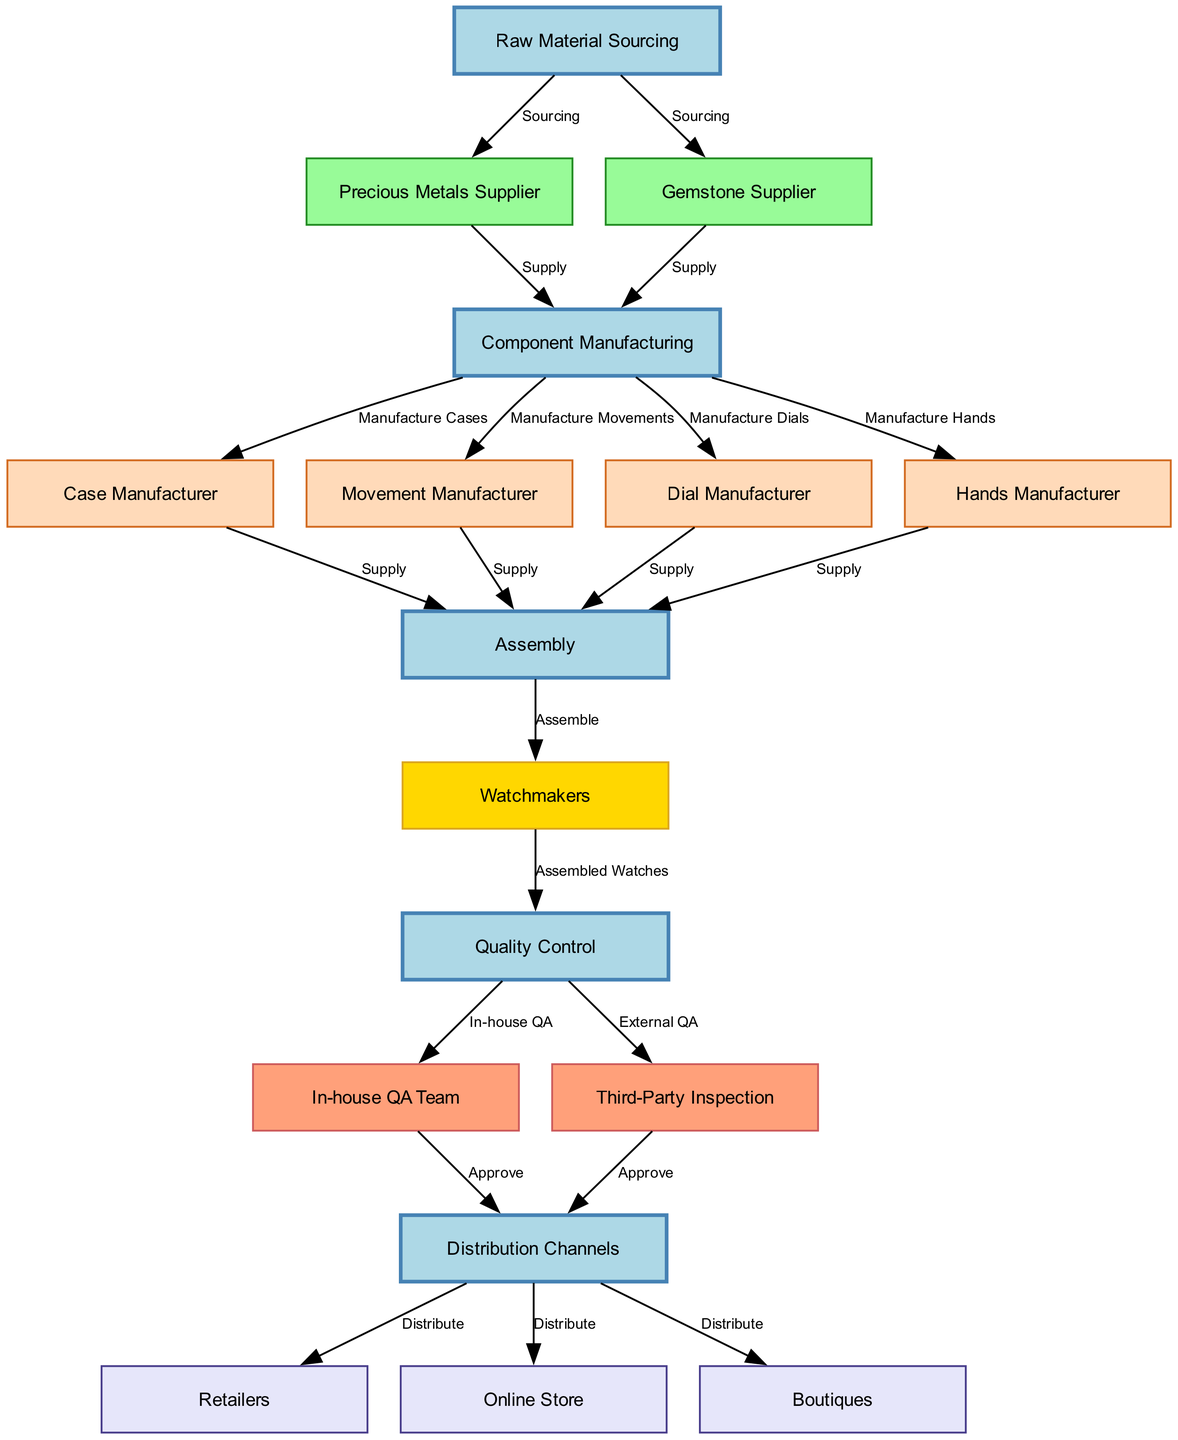What are the first two steps in the supply chain flow? The first step is "Raw Material Sourcing," followed by sourcing from "Precious Metals Supplier" and "Gemstone Supplier."
Answer: Raw Material Sourcing, Precious Metals Supplier, Gemstone Supplier How many manufacturers are involved in the component manufacturing phase? The diagram indicates there are four manufacturers involved: Case Manufacturer, Movement Manufacturer, Dial Manufacturer, and Hands Manufacturer.
Answer: Four What is the primary function of the "In-house QA Team"? The function of the "In-house QA Team" is to approve the assembled watches after the quality control checks are performed on them.
Answer: Approve Which node represents the final distribution of products? The node labeled "Distribution Channels" represents the final distribution point for the completed watches.
Answer: Distribution Channels What are the three distribution channels shown in the diagram? The three distribution channels are "Retailers," "Online Store," and "Boutiques."
Answer: Retailers, Online Store, Boutiques How does the assembly process connect the nodes? The assembly process connects from "Component Manufacturing" to "Assembly" and then to "Watchmakers," indicating direct involvement in the physical assembly of watches.
Answer: Assembly, Watchmakers What type of quality control is represented by "Third-Party Inspection"? "Third-Party Inspection" represents an external quality assurance step that checks the quality of watches after assembly.
Answer: External QA How many steps are involved from raw material sourcing to distribution? There are eight main steps in the flow from "Raw Material Sourcing" through various processes to reach "Distribution Channels."
Answer: Eight 